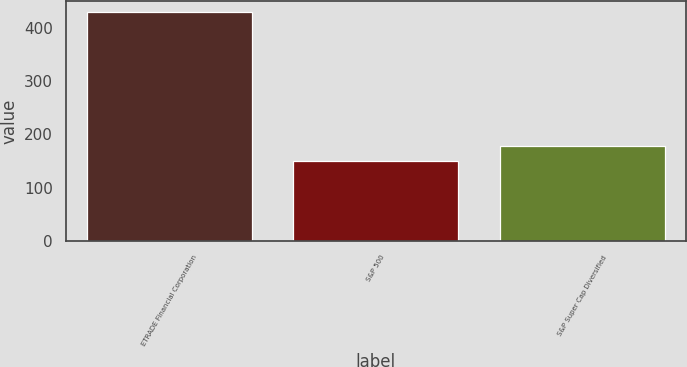Convert chart to OTSL. <chart><loc_0><loc_0><loc_500><loc_500><bar_chart><fcel>ETRADE Financial Corporation<fcel>S&P 500<fcel>S&P Super Cap Diversified<nl><fcel>429.22<fcel>149.7<fcel>177.65<nl></chart> 